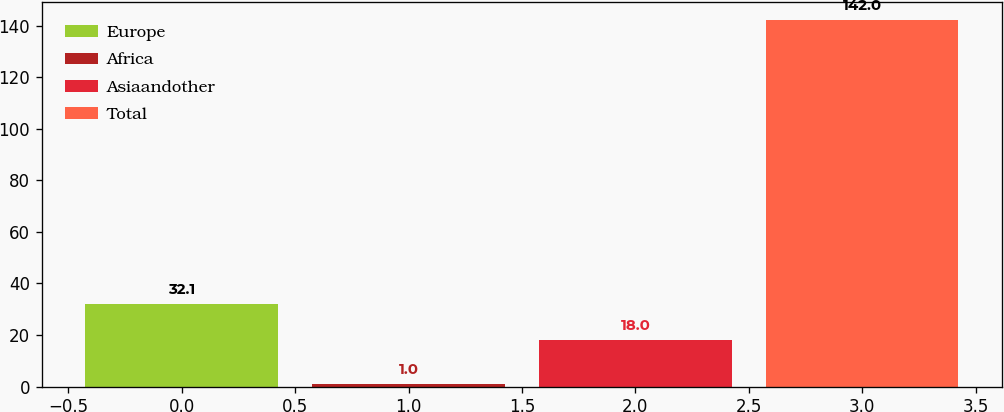Convert chart to OTSL. <chart><loc_0><loc_0><loc_500><loc_500><bar_chart><fcel>Europe<fcel>Africa<fcel>Asiaandother<fcel>Total<nl><fcel>32.1<fcel>1<fcel>18<fcel>142<nl></chart> 